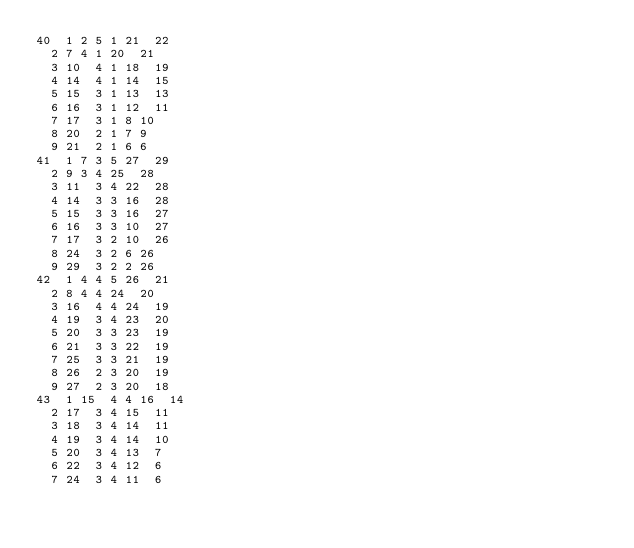Convert code to text. <code><loc_0><loc_0><loc_500><loc_500><_ObjectiveC_>40	1	2	5	1	21	22	
	2	7	4	1	20	21	
	3	10	4	1	18	19	
	4	14	4	1	14	15	
	5	15	3	1	13	13	
	6	16	3	1	12	11	
	7	17	3	1	8	10	
	8	20	2	1	7	9	
	9	21	2	1	6	6	
41	1	7	3	5	27	29	
	2	9	3	4	25	28	
	3	11	3	4	22	28	
	4	14	3	3	16	28	
	5	15	3	3	16	27	
	6	16	3	3	10	27	
	7	17	3	2	10	26	
	8	24	3	2	6	26	
	9	29	3	2	2	26	
42	1	4	4	5	26	21	
	2	8	4	4	24	20	
	3	16	4	4	24	19	
	4	19	3	4	23	20	
	5	20	3	3	23	19	
	6	21	3	3	22	19	
	7	25	3	3	21	19	
	8	26	2	3	20	19	
	9	27	2	3	20	18	
43	1	15	4	4	16	14	
	2	17	3	4	15	11	
	3	18	3	4	14	11	
	4	19	3	4	14	10	
	5	20	3	4	13	7	
	6	22	3	4	12	6	
	7	24	3	4	11	6	</code> 